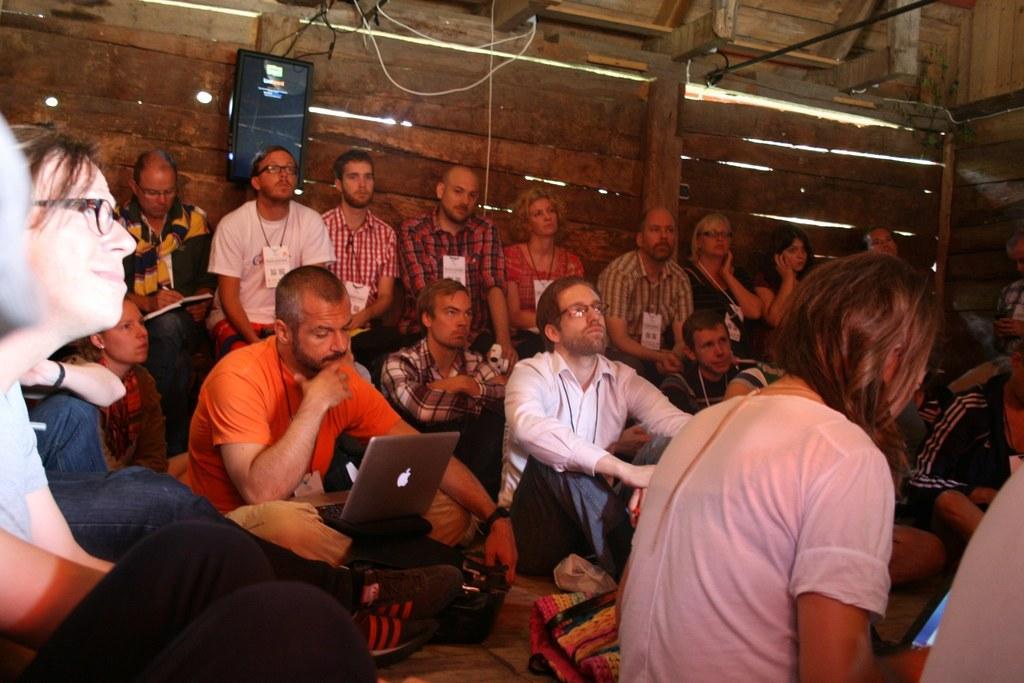Please provide a concise description of this image. In this picture there is a man who is sitting on the left side of the image and there is a laptop on his laps and there are other people on the right and left side of image and there is a screen in the background area of the image and there is a wooden roof at the top side of the image. 